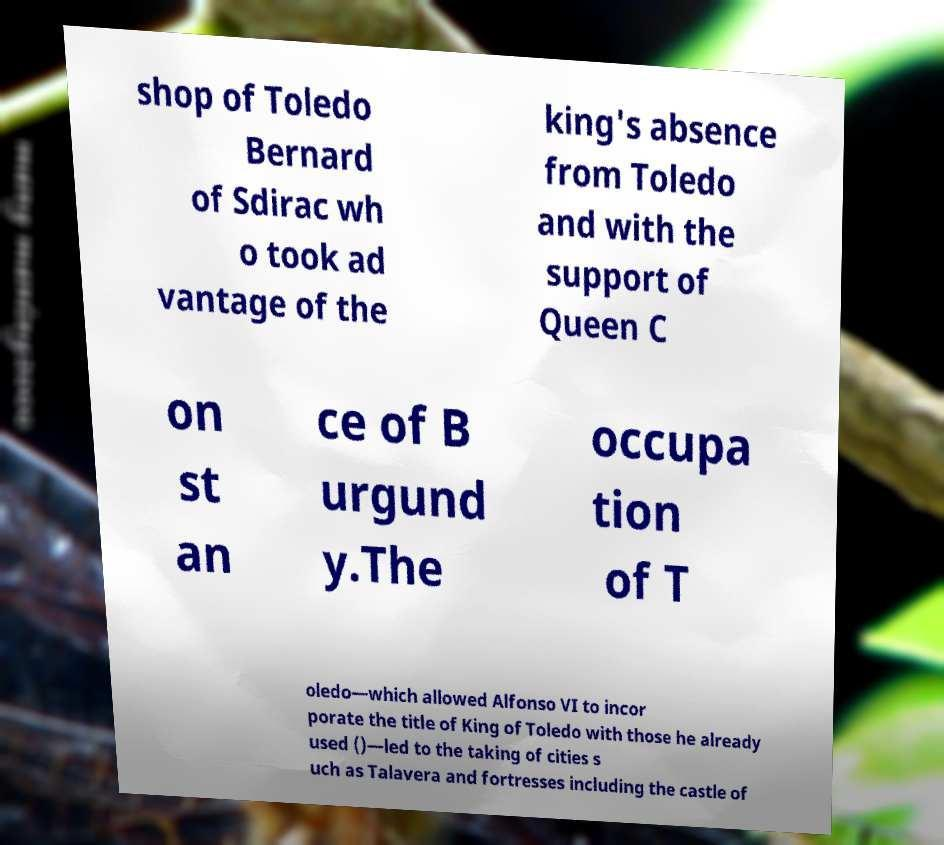Can you accurately transcribe the text from the provided image for me? shop of Toledo Bernard of Sdirac wh o took ad vantage of the king's absence from Toledo and with the support of Queen C on st an ce of B urgund y.The occupa tion of T oledo—which allowed Alfonso VI to incor porate the title of King of Toledo with those he already used ()—led to the taking of cities s uch as Talavera and fortresses including the castle of 